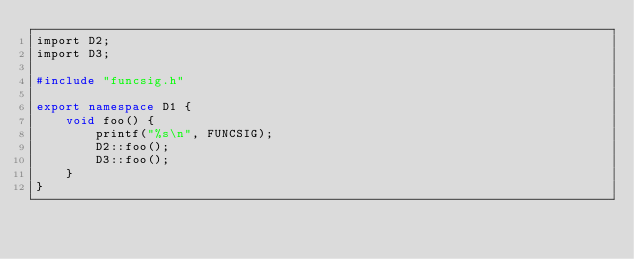Convert code to text. <code><loc_0><loc_0><loc_500><loc_500><_C++_>import D2;
import D3;

#include "funcsig.h"

export namespace D1 {
	void foo() {
		printf("%s\n", FUNCSIG);
		D2::foo();
		D3::foo();
	}
}</code> 